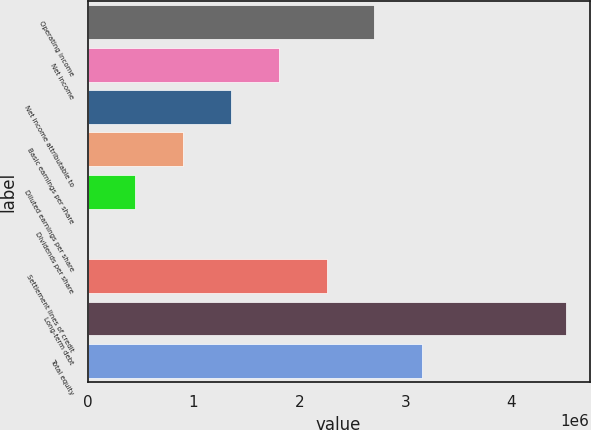<chart> <loc_0><loc_0><loc_500><loc_500><bar_chart><fcel>Operating income<fcel>Net income<fcel>Net income attributable to<fcel>Basic earnings per share<fcel>Diluted earnings per share<fcel>Dividends per share<fcel>Settlement lines of credit<fcel>Long-term debt<fcel>Total equity<nl><fcel>2.70917e+06<fcel>1.80611e+06<fcel>1.35459e+06<fcel>903057<fcel>451529<fcel>0.04<fcel>2.25764e+06<fcel>4.51529e+06<fcel>3.1607e+06<nl></chart> 